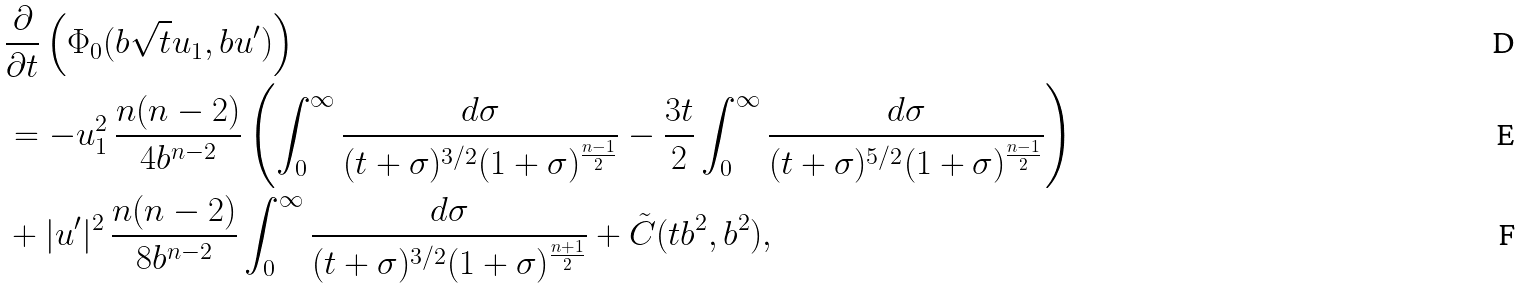<formula> <loc_0><loc_0><loc_500><loc_500>& \frac { \partial } { \partial t } \left ( \Phi _ { 0 } ( b \sqrt { t } u _ { 1 } , b u ^ { \prime } ) \right ) \\ & = - u _ { 1 } ^ { 2 } \, \frac { n ( n - 2 ) } { 4 b ^ { n - 2 } } \left ( \int _ { 0 } ^ { \infty } \frac { d \sigma } { ( t + \sigma ) ^ { 3 / 2 } ( 1 + \sigma ) ^ { \frac { n - 1 } 2 } } - \frac { 3 t } 2 \int _ { 0 } ^ { \infty } \frac { d \sigma } { ( t + \sigma ) ^ { 5 / 2 } ( 1 + \sigma ) ^ { \frac { n - 1 } 2 } } \right ) \\ & + | u ^ { \prime } | ^ { 2 } \, \frac { n ( n - 2 ) } { 8 b ^ { n - 2 } } \int _ { 0 } ^ { \infty } \frac { d \sigma } { ( t + \sigma ) ^ { 3 / 2 } ( 1 + \sigma ) ^ { \frac { n + 1 } 2 } } + \tilde { C } ( t b ^ { 2 } , b ^ { 2 } ) ,</formula> 